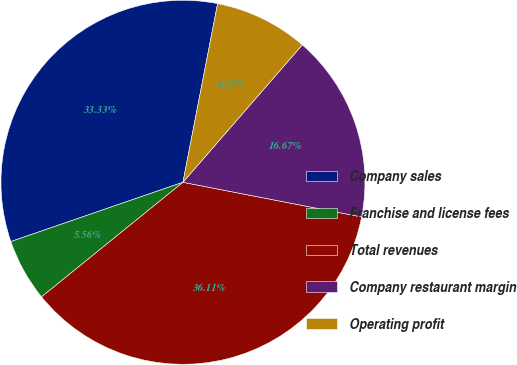Convert chart to OTSL. <chart><loc_0><loc_0><loc_500><loc_500><pie_chart><fcel>Company sales<fcel>Franchise and license fees<fcel>Total revenues<fcel>Company restaurant margin<fcel>Operating profit<nl><fcel>33.33%<fcel>5.56%<fcel>36.11%<fcel>16.67%<fcel>8.33%<nl></chart> 